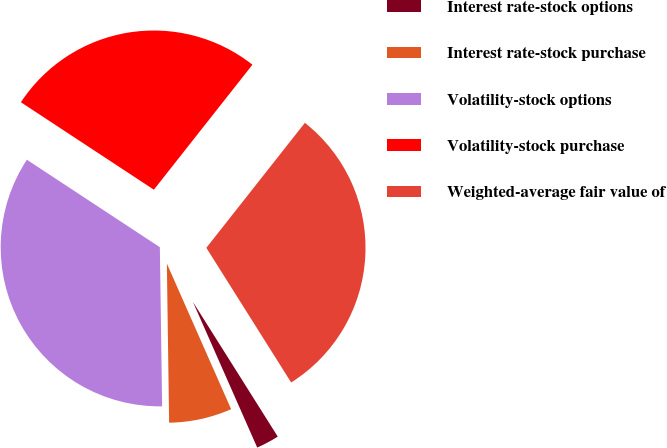<chart> <loc_0><loc_0><loc_500><loc_500><pie_chart><fcel>Interest rate-stock options<fcel>Interest rate-stock purchase<fcel>Volatility-stock options<fcel>Volatility-stock purchase<fcel>Weighted-average fair value of<nl><fcel>2.33%<fcel>6.39%<fcel>34.49%<fcel>26.37%<fcel>30.43%<nl></chart> 